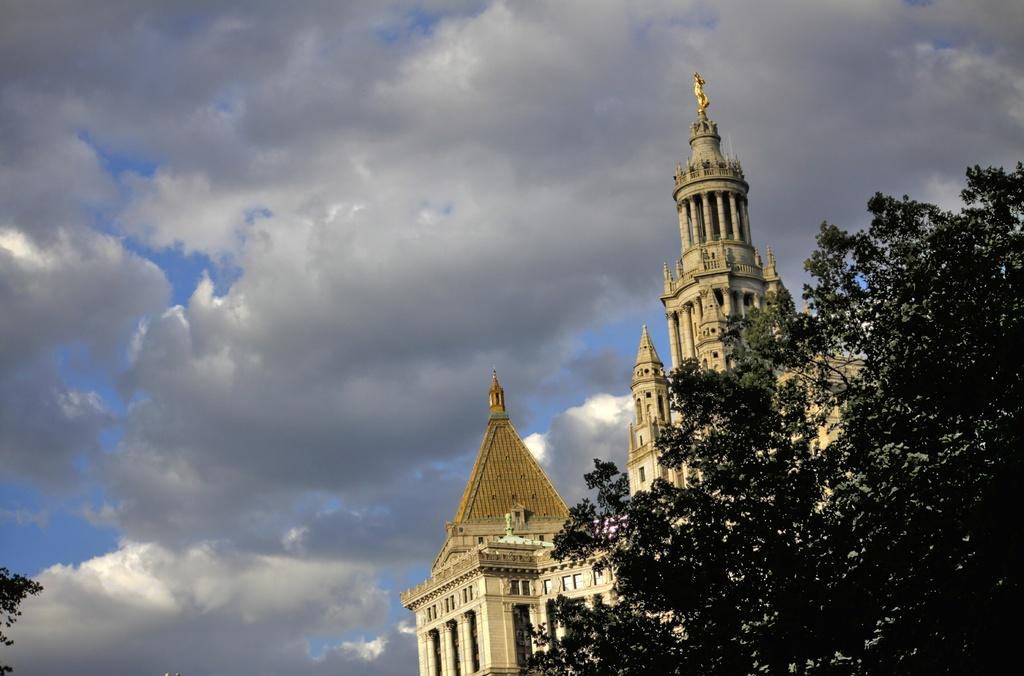What type of structures can be seen in the image? There are buildings in the image. What other natural elements are present in the image? There are trees in the image. What can be seen in the distance in the image? The sky is visible in the background of the image. What type of ink is being used to draw the trees in the image? There is no indication that the trees in the image are drawn or that ink is being used; they appear to be natural trees. 